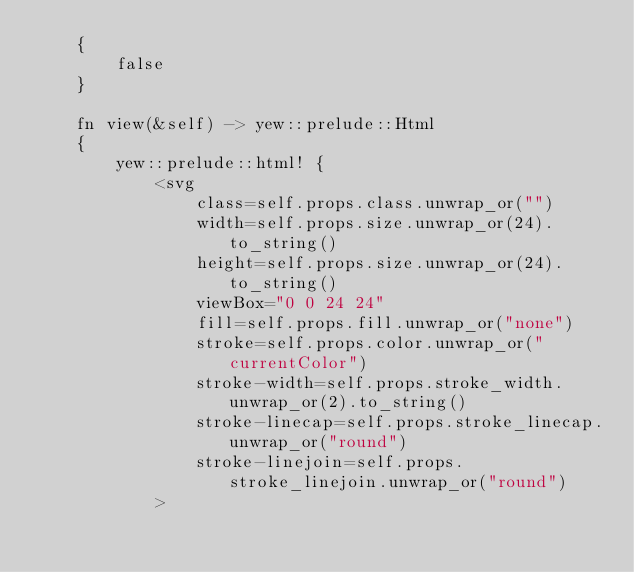Convert code to text. <code><loc_0><loc_0><loc_500><loc_500><_Rust_>    {
        false
    }

    fn view(&self) -> yew::prelude::Html
    {
        yew::prelude::html! {
            <svg
                class=self.props.class.unwrap_or("")
                width=self.props.size.unwrap_or(24).to_string()
                height=self.props.size.unwrap_or(24).to_string()
                viewBox="0 0 24 24"
                fill=self.props.fill.unwrap_or("none")
                stroke=self.props.color.unwrap_or("currentColor")
                stroke-width=self.props.stroke_width.unwrap_or(2).to_string()
                stroke-linecap=self.props.stroke_linecap.unwrap_or("round")
                stroke-linejoin=self.props.stroke_linejoin.unwrap_or("round")
            ></code> 